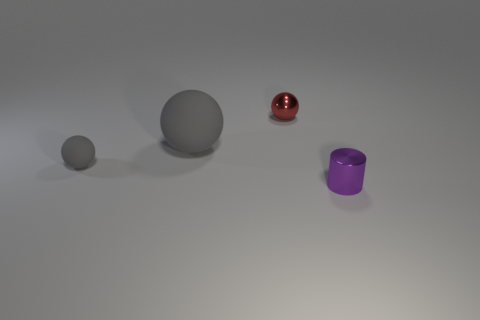Are there any other things that are the same size as the metal sphere?
Your answer should be very brief. Yes. Are there any other things that are the same shape as the big thing?
Your answer should be very brief. Yes. There is a tiny thing that is on the right side of the red object; what is it made of?
Ensure brevity in your answer.  Metal. There is another gray thing that is the same shape as the tiny gray rubber thing; what is its size?
Provide a succinct answer. Large. What number of purple objects are the same material as the red object?
Keep it short and to the point. 1. How many tiny spheres are the same color as the large matte ball?
Offer a very short reply. 1. How many things are either small metal balls behind the tiny purple cylinder or shiny objects behind the tiny purple thing?
Ensure brevity in your answer.  1. Is the number of purple things in front of the red sphere less than the number of small gray things?
Your response must be concise. No. Are there any rubber objects that have the same size as the metal cylinder?
Make the answer very short. Yes. The tiny cylinder has what color?
Keep it short and to the point. Purple. 